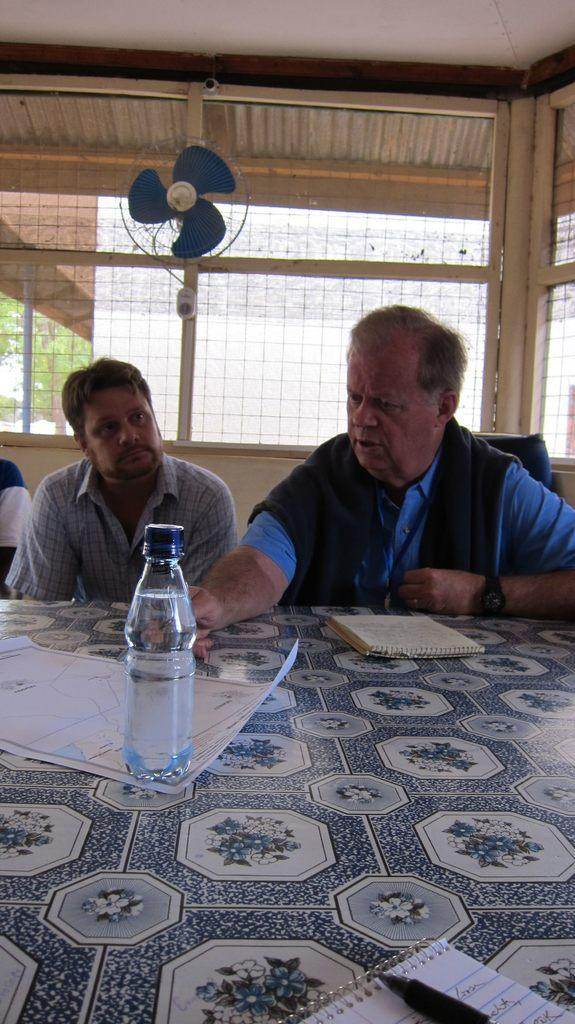How many people are in the image? There are two persons in the image. What are the two persons doing in the image? The two persons are sitting in front of a table. Can you describe any objects on the wall in the image? Yes, there is a fan on the wall in the image. What type of structure is visible in the image? There is a wall in the image. What direction is the ring facing in the image? There is no ring present in the image, so it is not possible to determine the direction it might be facing. 